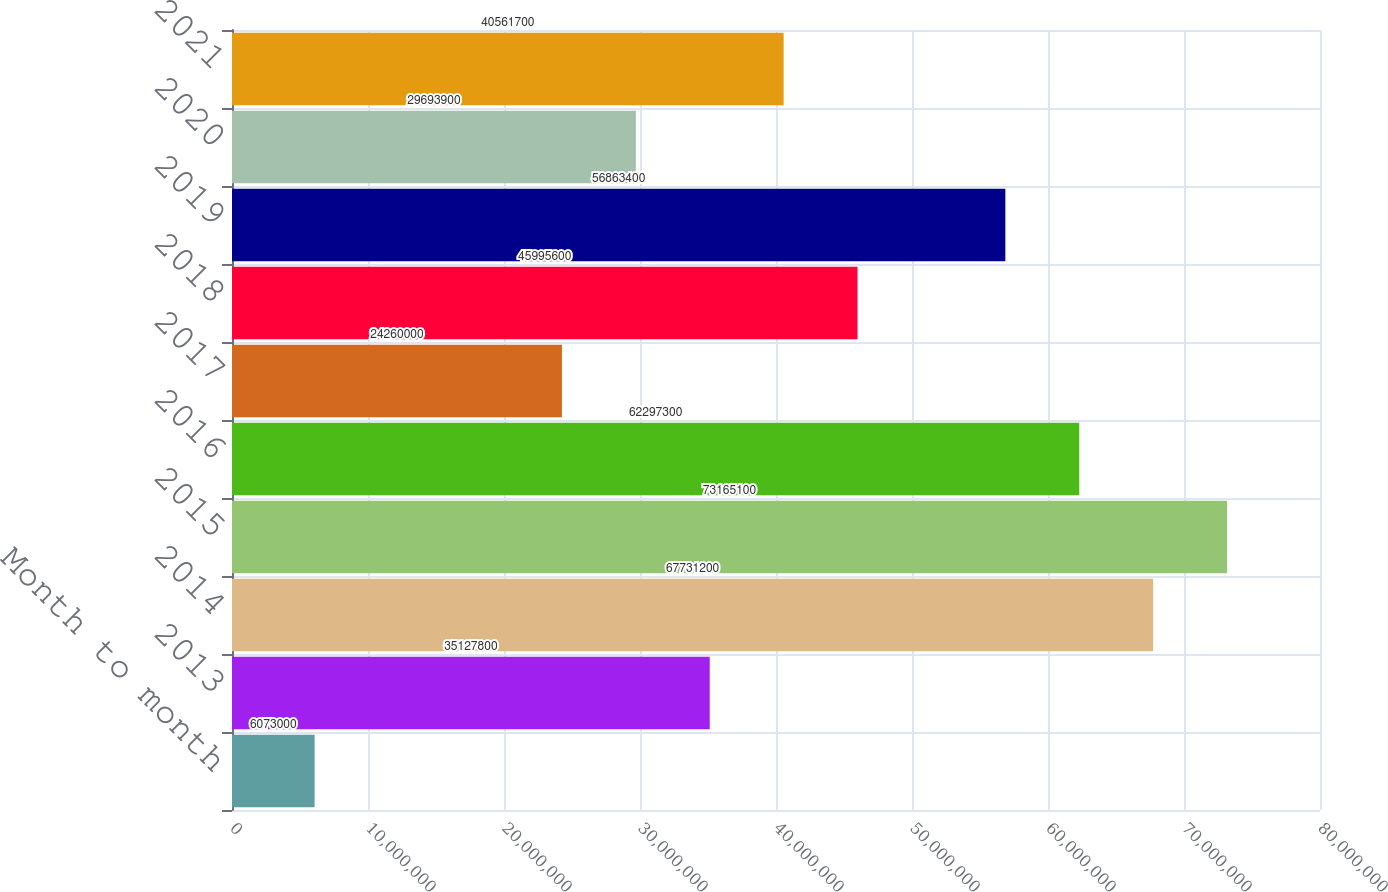<chart> <loc_0><loc_0><loc_500><loc_500><bar_chart><fcel>Month to month<fcel>2013<fcel>2014<fcel>2015<fcel>2016<fcel>2017<fcel>2018<fcel>2019<fcel>2020<fcel>2021<nl><fcel>6.073e+06<fcel>3.51278e+07<fcel>6.77312e+07<fcel>7.31651e+07<fcel>6.22973e+07<fcel>2.426e+07<fcel>4.59956e+07<fcel>5.68634e+07<fcel>2.96939e+07<fcel>4.05617e+07<nl></chart> 